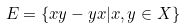Convert formula to latex. <formula><loc_0><loc_0><loc_500><loc_500>E = \{ x y - y x | x , y \in X \}</formula> 